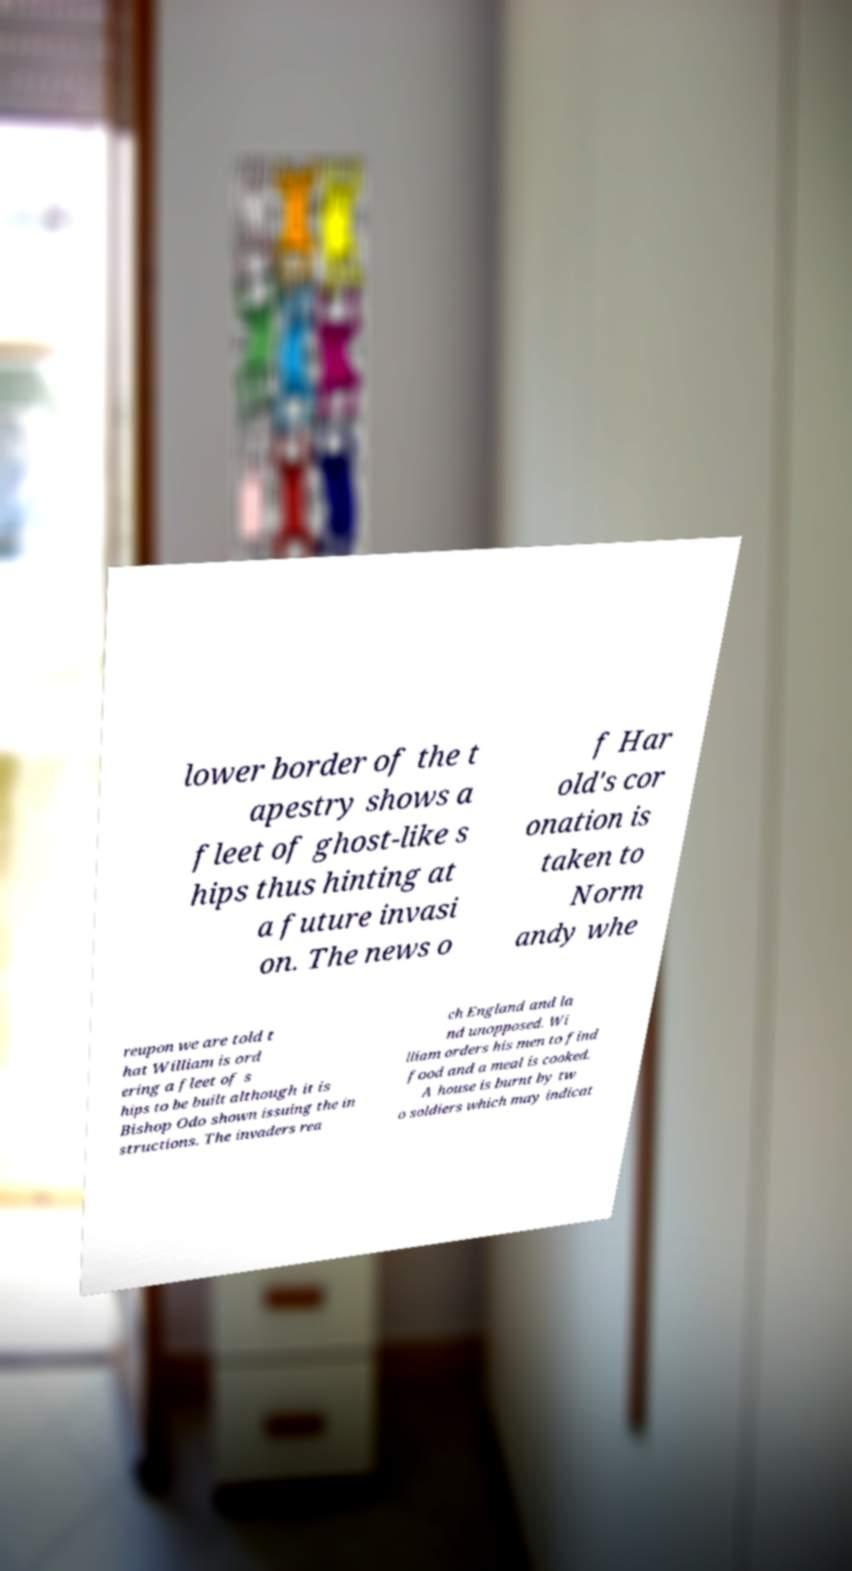Could you assist in decoding the text presented in this image and type it out clearly? lower border of the t apestry shows a fleet of ghost-like s hips thus hinting at a future invasi on. The news o f Har old's cor onation is taken to Norm andy whe reupon we are told t hat William is ord ering a fleet of s hips to be built although it is Bishop Odo shown issuing the in structions. The invaders rea ch England and la nd unopposed. Wi lliam orders his men to find food and a meal is cooked. A house is burnt by tw o soldiers which may indicat 